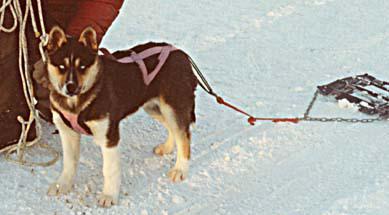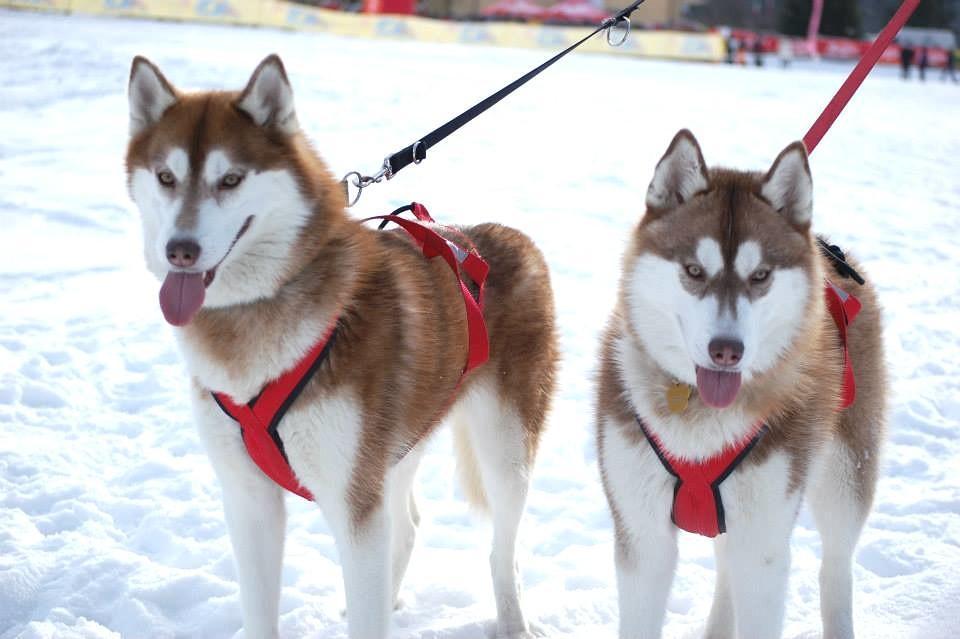The first image is the image on the left, the second image is the image on the right. Examine the images to the left and right. Is the description "Some dogs are moving forward." accurate? Answer yes or no. No. The first image is the image on the left, the second image is the image on the right. For the images shown, is this caption "There are two huskies in red harness standing on the snow." true? Answer yes or no. Yes. 